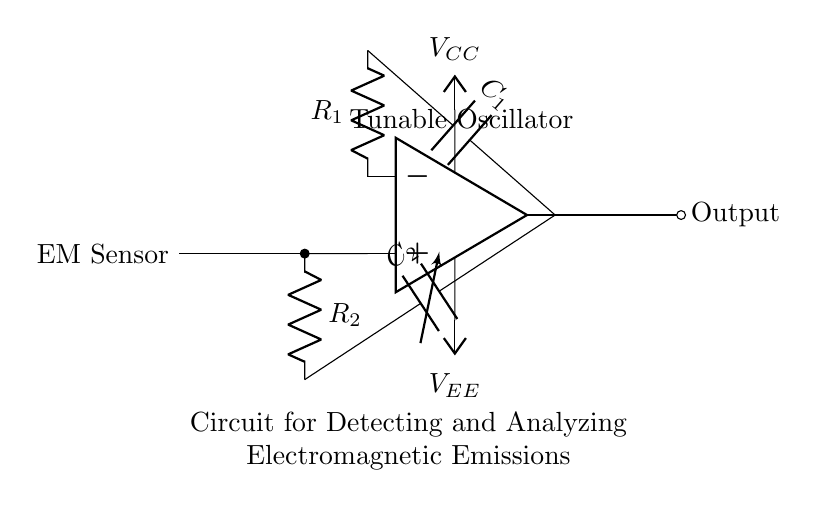What type of components are in this circuit? The circuit consists mainly of resistors, capacitors, an operational amplifier, and an antenna, which are typical elements used in oscillator circuits.
Answer: resistors, capacitors, operational amplifier, antenna What is the role of the variable capacitor in this circuit? The variable capacitor acts as a tuning element, allowing the circuit to adjust its oscillator frequency by changing its capacitance.
Answer: tuning element What does the output of this oscillator represent? The output of the oscillator represents the detected and amplified electromagnetic signals from electronic devices through the antenna.
Answer: detected electromagnetic signals Which component provides power to the oscillator circuit? The power supply is responsible for providing the necessary voltage to the circuit, specifically the components labeled as V_CC and V_EE.
Answer: power supply How is the frequency of the oscillator affected? The frequency can be varied by adjusting the values of the resistors and capacitors, particularly the variable capacitor that adjusts the circuit’s resonant frequency.
Answer: varying resistors and capacitors What is the purpose of the antenna in this circuit? The antenna is used to capture electromagnetic emissions from surrounding electronic devices, effectively transforming them into electrical signals for further analysis by the oscillator.
Answer: capture electromagnetic emissions What is the basic function of the operational amplifier in this circuit? The operational amplifier amplifies the input signals from the antenna, boosting the weak electromagnetic signals for better detection and analysis.
Answer: amplifies signals 